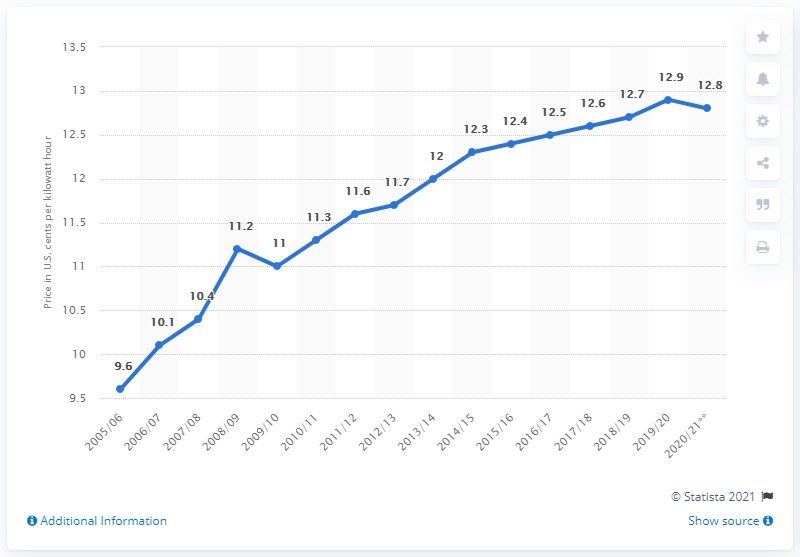Indicate a few pertinent items in this graphic. In the winter of 2019/20, the average price per kilowatt hour was 12.9 cents. 